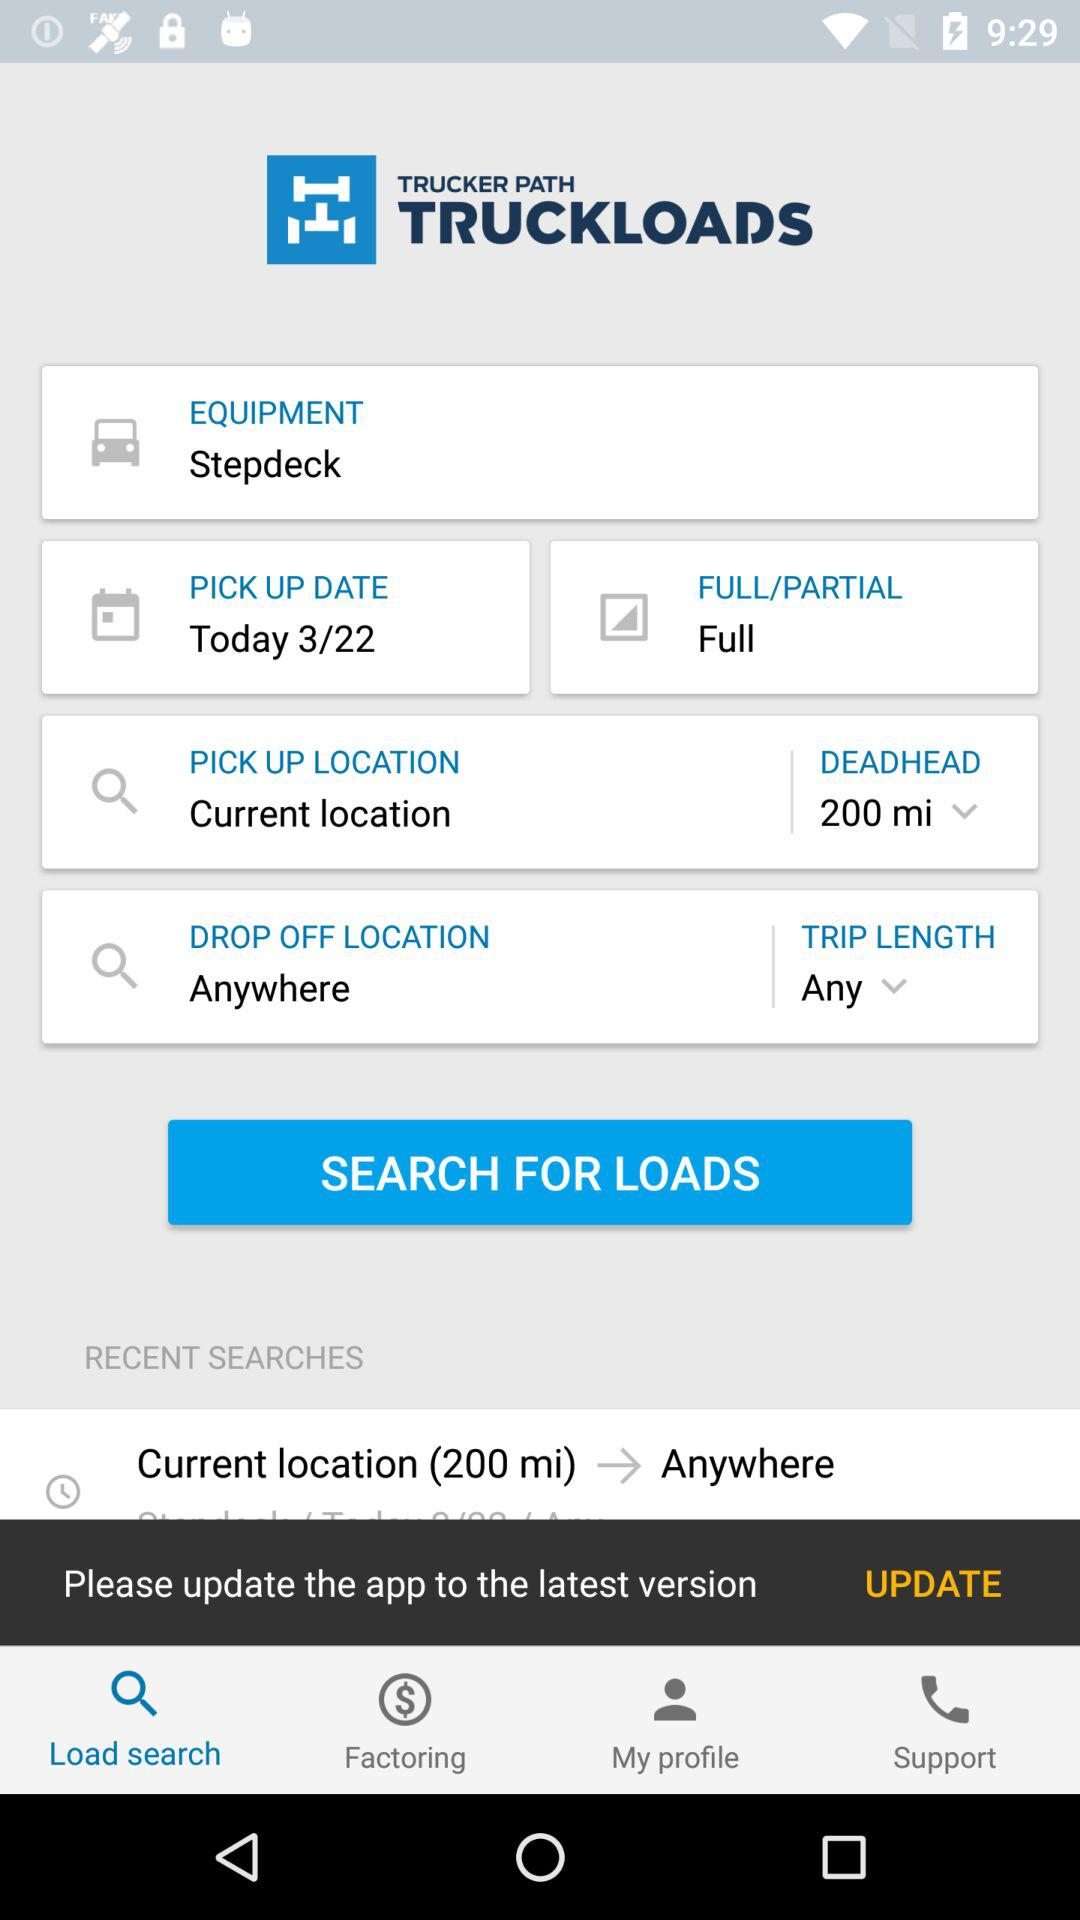What is the application name? The application name is "TRUCKER PATH TRUCKLOADS". 